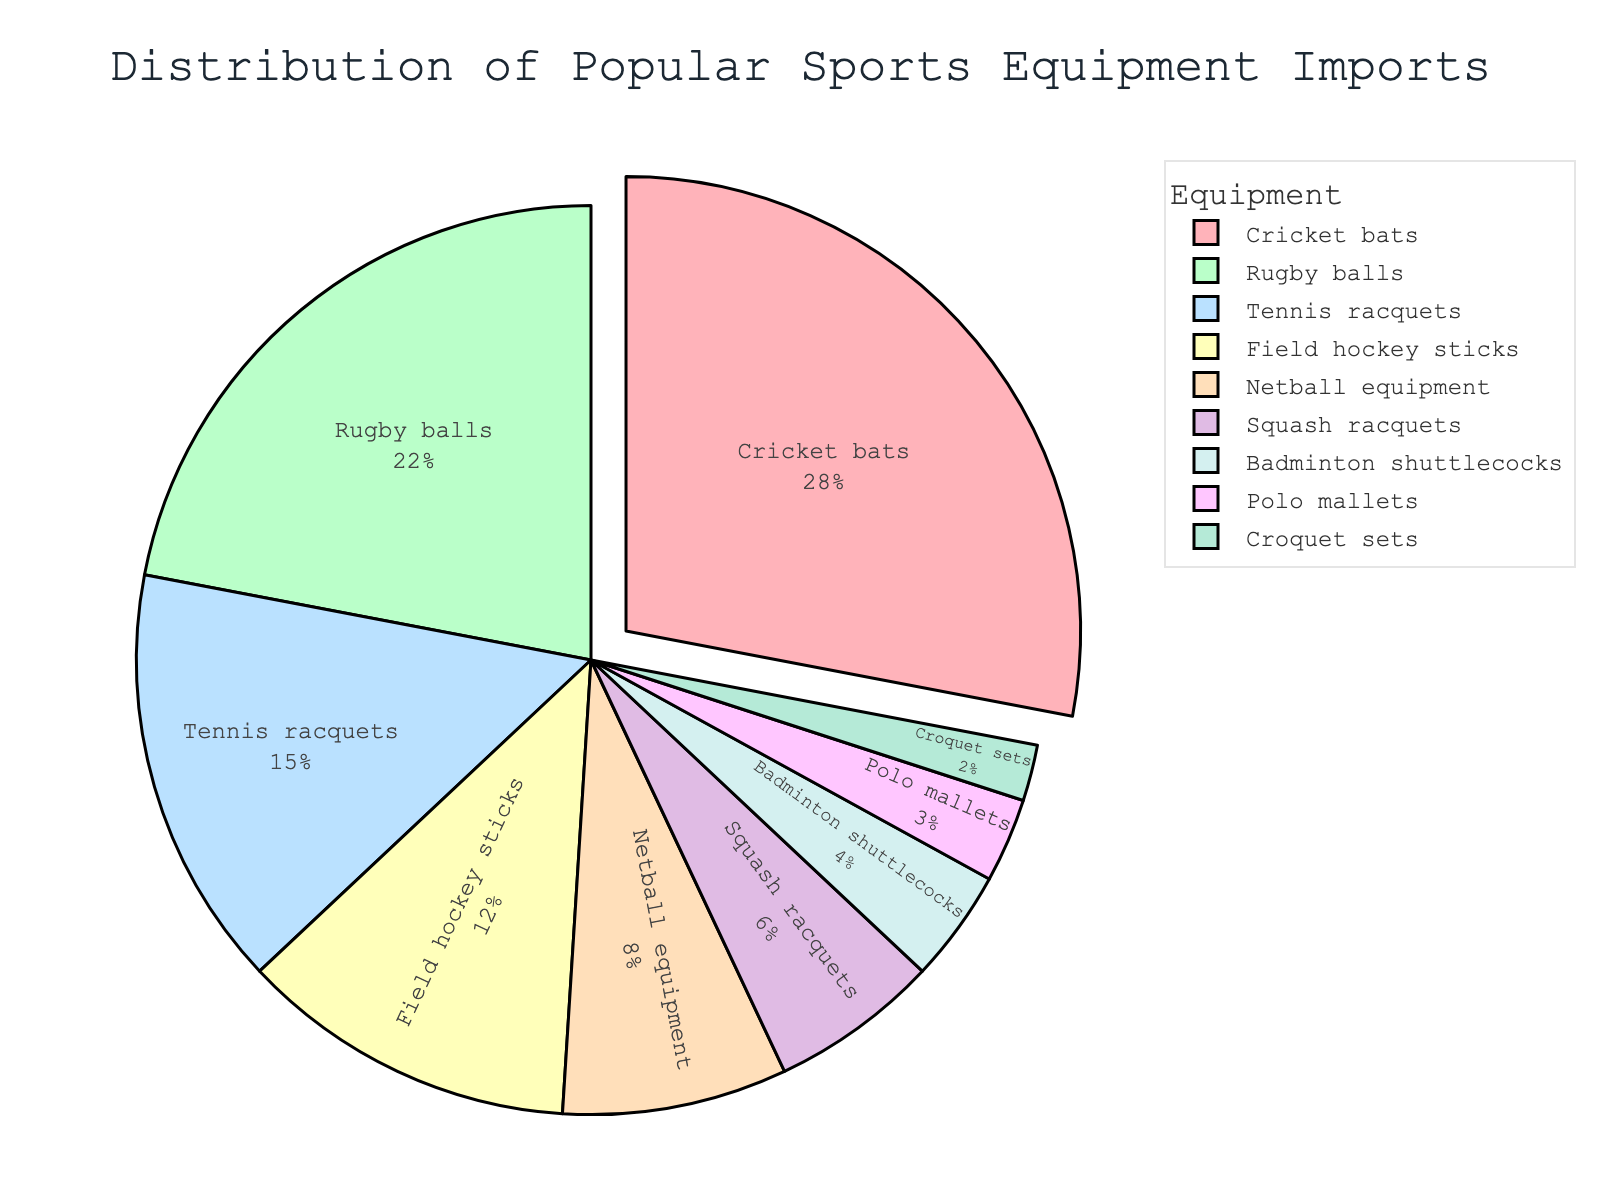Which sports equipment has the highest percentage of imports? The pie chart shows that the slice labeled "Cricket bats" is the largest, indicating the highest percentage of imports.
Answer: Cricket bats What is the combined percentage of imports for rugby balls and tennis racquets? From the pie chart, we add the percentages for rugby balls (22%) and tennis racquets (15%): 22 + 15 = 37.
Answer: 37% Is the percentage for badminton shuttlecocks greater than or less than that for polo mallets? By looking at the pie chart, we can see that the slice for badminton shuttlecocks (4%) is larger than the slice for polo mallets (3%).
Answer: Greater What sports equipment is associated with the smallest slice in the pie chart? The smallest slice in the pie chart is labeled "Croquet sets," with a percentage of 2%.
Answer: Croquet sets How many sports equipment categories have a percentage greater than 10%? Looking at the pie chart, we identify categories with percentages greater than 10%, which are cricket bats (28%), rugby balls (22%), tennis racquets (15%), and field hockey sticks (12%). Four categories meet this criterion.
Answer: 4 What is the difference in import percentage between squash racquets and netball equipment? The pie chart shows that squach racquets have an import percentage of 6% and netball equipment has 8%. The difference is 8 - 6 = 2.
Answer: 2% Which sports have import percentages that sum up to less than 10%? From the pie chart, we need to find categories with the smallest percentages that sum to less than 10%. We see that croquet sets (2%), polo mallets (3%), and badminton shuttlecocks (4%) sum up to 9%.
Answer: Croquet sets, Polo mallets, Badminton shuttlecocks What color represents netball equipment in the pie chart? The pie chart uses a custom color palette. The slice labeled "Netball equipment" is colored yellow.
Answer: Yellow 